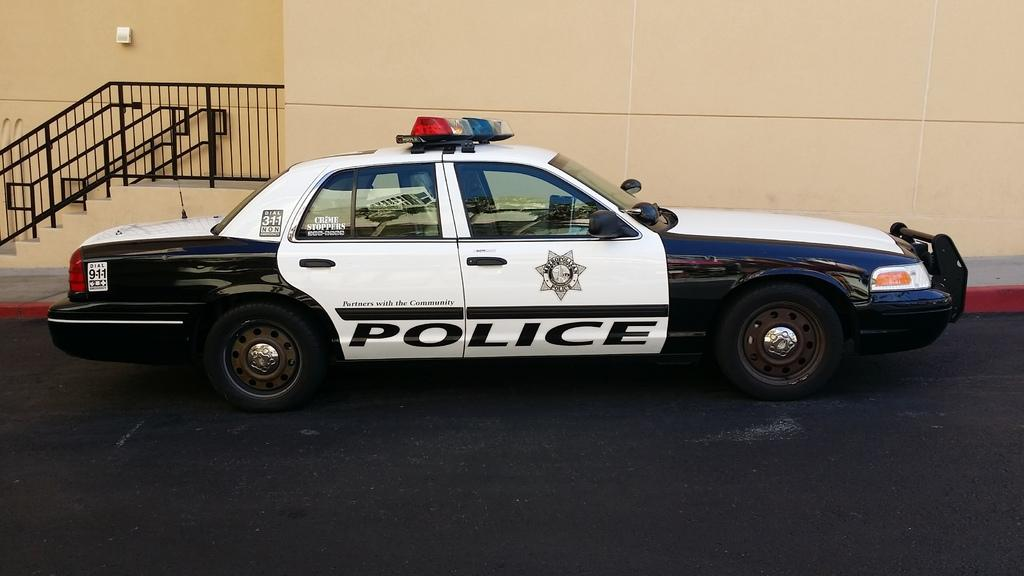What is the main subject of the image? The main subject of the image is a car on the road. What can be seen behind the car? There is a wall behind the car. What architectural feature is on the left side of the image? There are stairs on the left side of the image. What safety feature is present in the image? There are railings in the image. What type of wax can be seen melting on the car in the image? There is no wax present in the image, and therefore no wax can be seen melting on the car. 